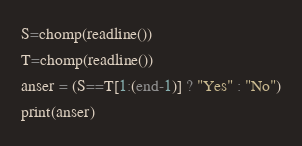<code> <loc_0><loc_0><loc_500><loc_500><_Julia_>S=chomp(readline())
T=chomp(readline())
anser = (S==T[1:(end-1)] ? "Yes" : "No")
print(anser)</code> 